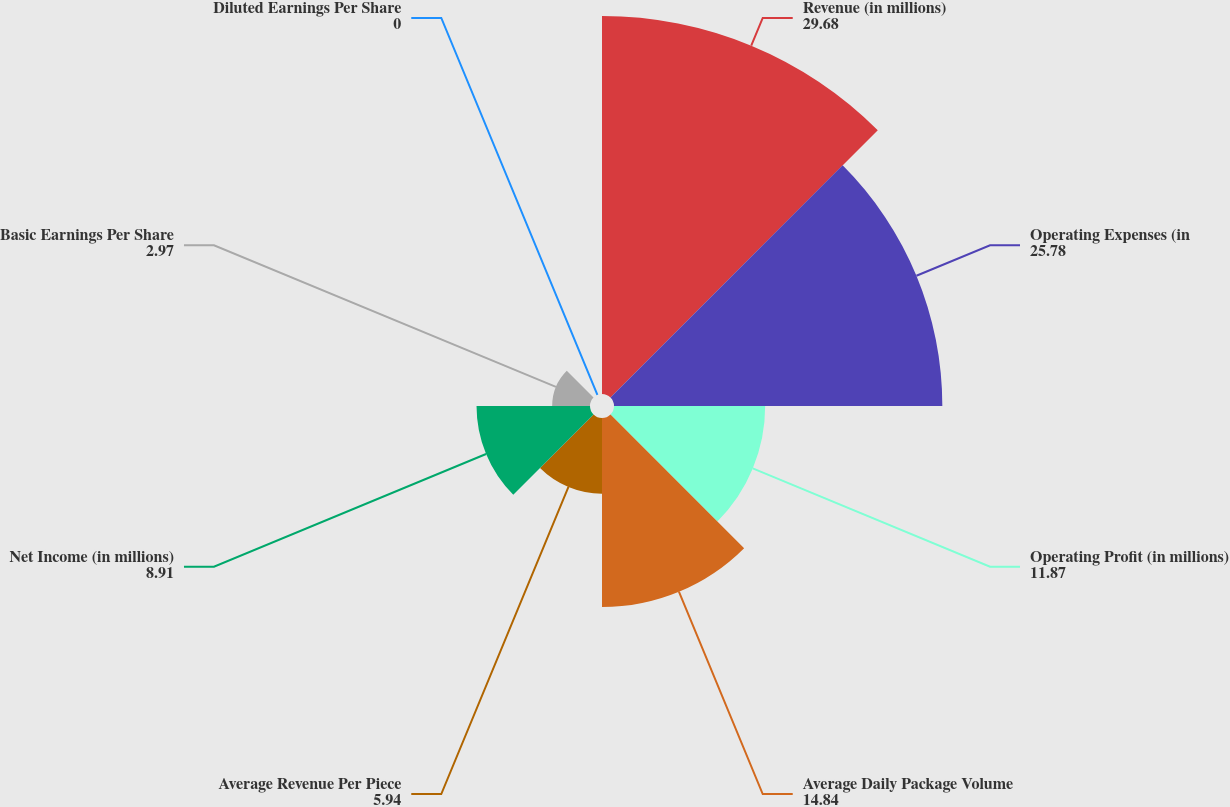Convert chart. <chart><loc_0><loc_0><loc_500><loc_500><pie_chart><fcel>Revenue (in millions)<fcel>Operating Expenses (in<fcel>Operating Profit (in millions)<fcel>Average Daily Package Volume<fcel>Average Revenue Per Piece<fcel>Net Income (in millions)<fcel>Basic Earnings Per Share<fcel>Diluted Earnings Per Share<nl><fcel>29.68%<fcel>25.78%<fcel>11.87%<fcel>14.84%<fcel>5.94%<fcel>8.91%<fcel>2.97%<fcel>0.0%<nl></chart> 